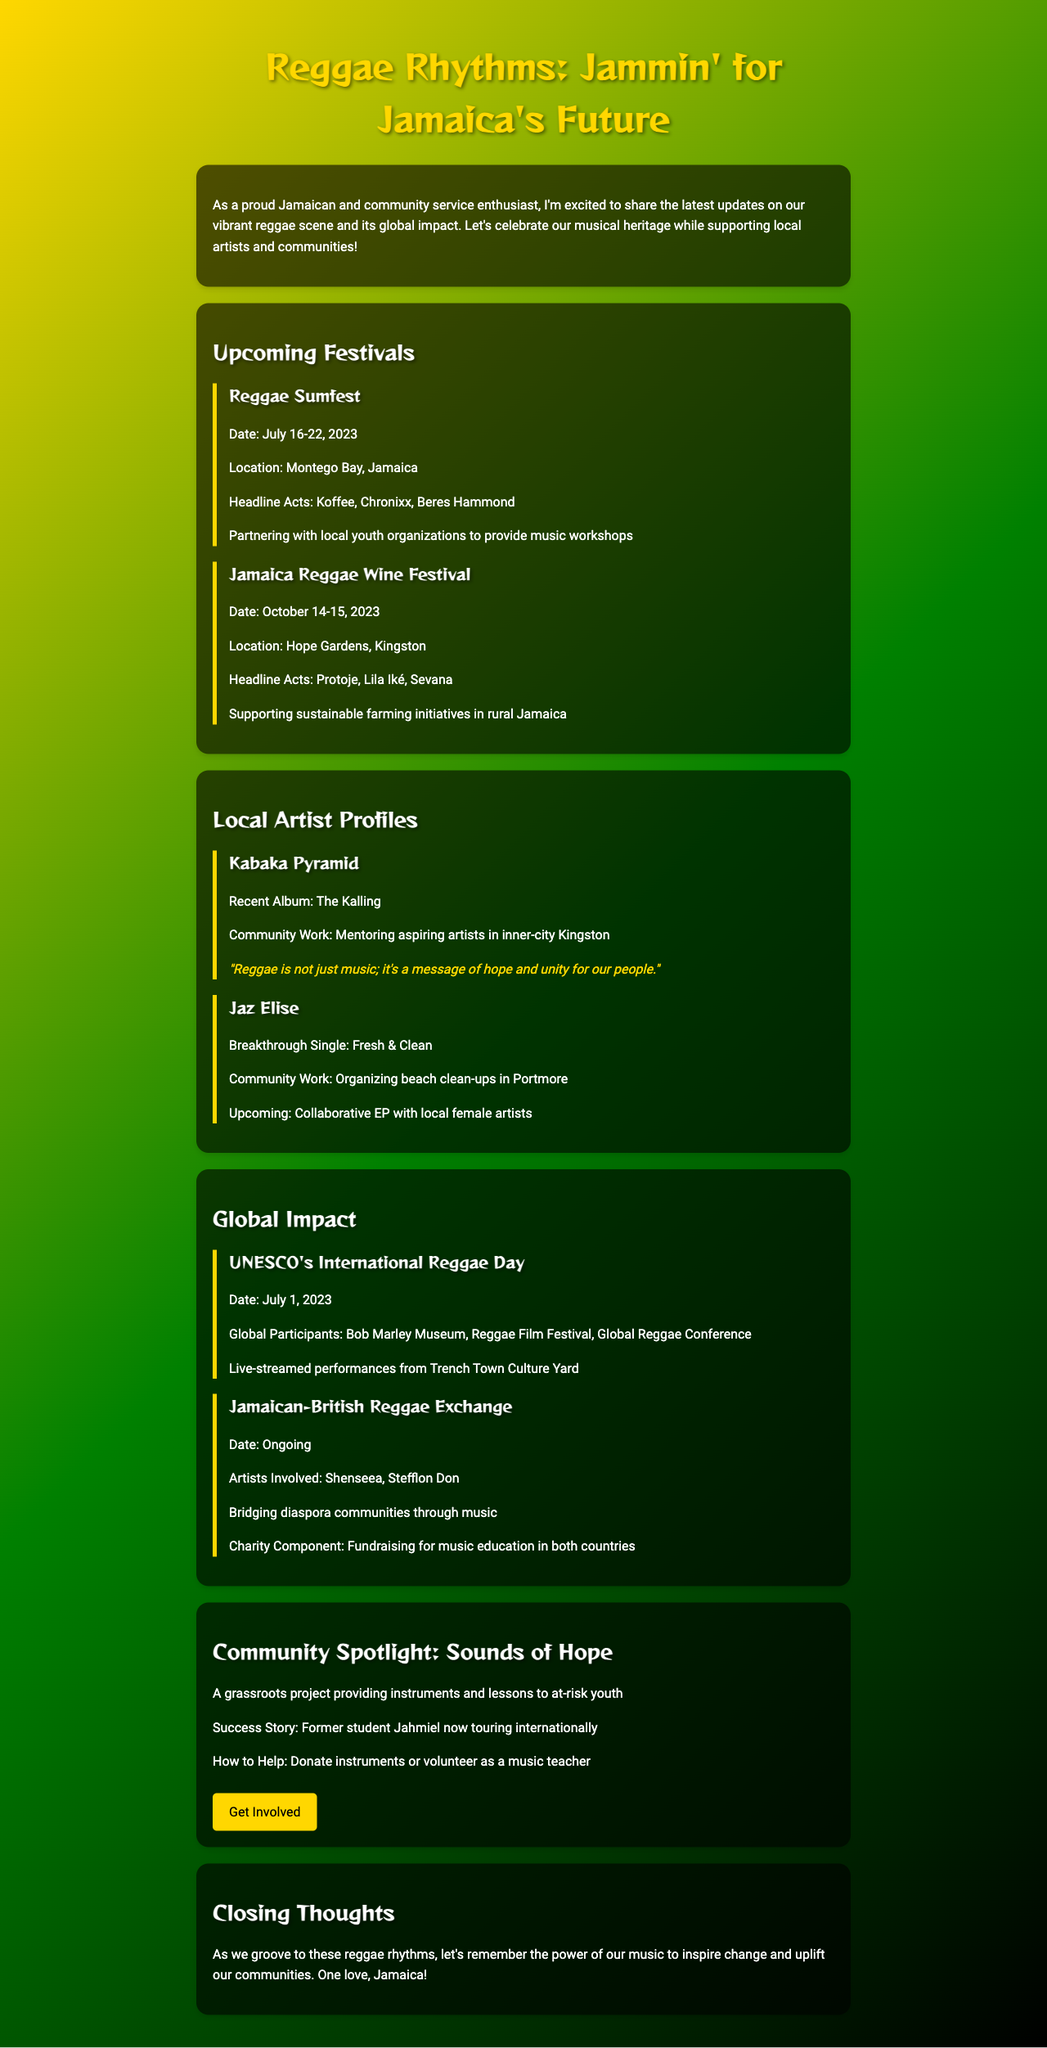what is the name of the first upcoming festival? The first upcoming festival listed in the document is 'Reggae Sumfest'.
Answer: Reggae Sumfest when is the Jamaica Reggae Wine Festival scheduled? The document states that the Jamaica Reggae Wine Festival is scheduled for October 14-15, 2023.
Answer: October 14-15, 2023 who is the featured artist at the Jamaica Reggae Wine Festival? The highlighted artists for the Jamaica Reggae Wine Festival are Protoje, Lila Iké, and Sevana.
Answer: Protoje, Lila Iké, Sevana what is the community focus of Reggae Sumfest? The document mentions that Reggae Sumfest is partnering with local youth organizations to provide music workshops.
Answer: Partnering with local youth organizations to provide music workshops which local artist organized beach clean-ups? The artist who is organizing beach clean-ups is Jaz Elise.
Answer: Jaz Elise what significant event celebrated reggae on July 1, 2023? The document indicates that UNESCO's International Reggae Day celebrated reggae on July 1, 2023.
Answer: UNESCO's International Reggae Day how does the Jamaican-British Reggae Exchange contribute to charity? It raises funds for music education in both Jamaica and the UK.
Answer: Fundraising for music education in both countries what is the name of the community initiative providing music lessons to at-risk youth? The community initiative mentioned in the document is called 'Sounds of Hope'.
Answer: Sounds of Hope 